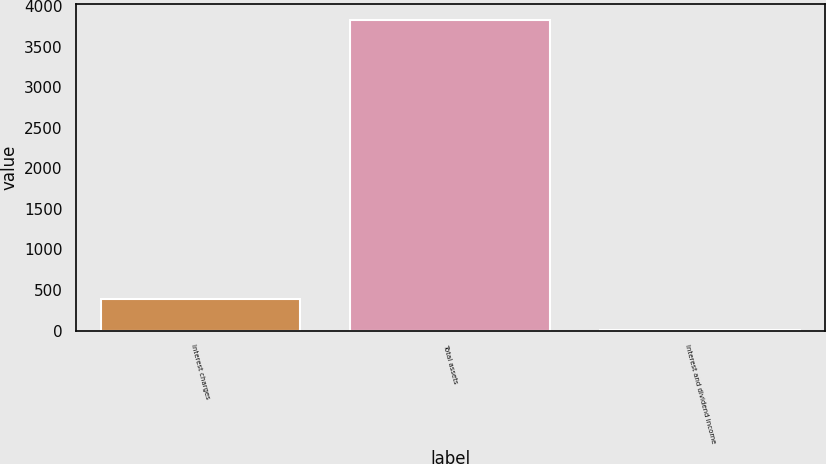Convert chart. <chart><loc_0><loc_0><loc_500><loc_500><bar_chart><fcel>Interest charges<fcel>Total assets<fcel>Interest and dividend income<nl><fcel>384.2<fcel>3833<fcel>1<nl></chart> 